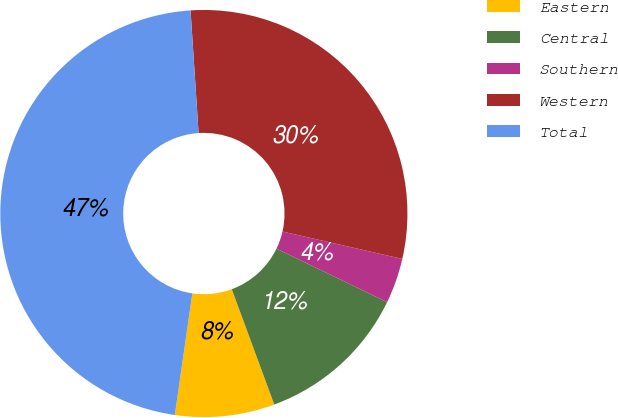Convert chart. <chart><loc_0><loc_0><loc_500><loc_500><pie_chart><fcel>Eastern<fcel>Central<fcel>Southern<fcel>Western<fcel>Total<nl><fcel>7.9%<fcel>12.21%<fcel>3.59%<fcel>29.62%<fcel>46.68%<nl></chart> 